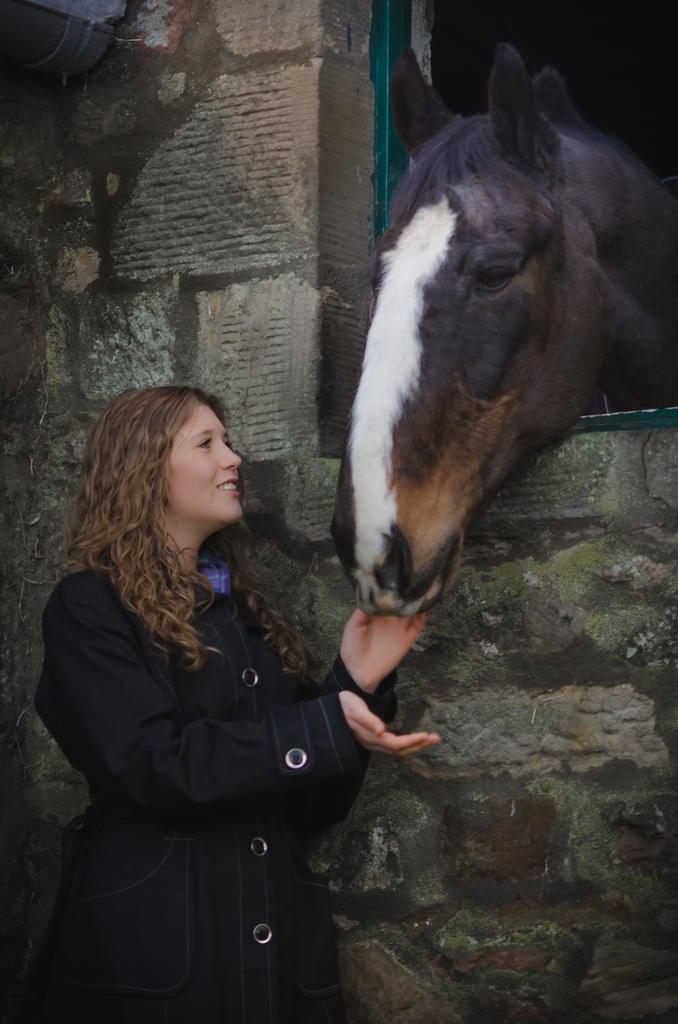Who is the main subject in the image? There is a woman in the image. What is the woman wearing? The woman is wearing a black jacket. What is the woman doing in the image? The woman is holding a horse with her hand. What is the title of the book the woman is reading in the image? There is no book present in the image, and therefore no title to mention. 